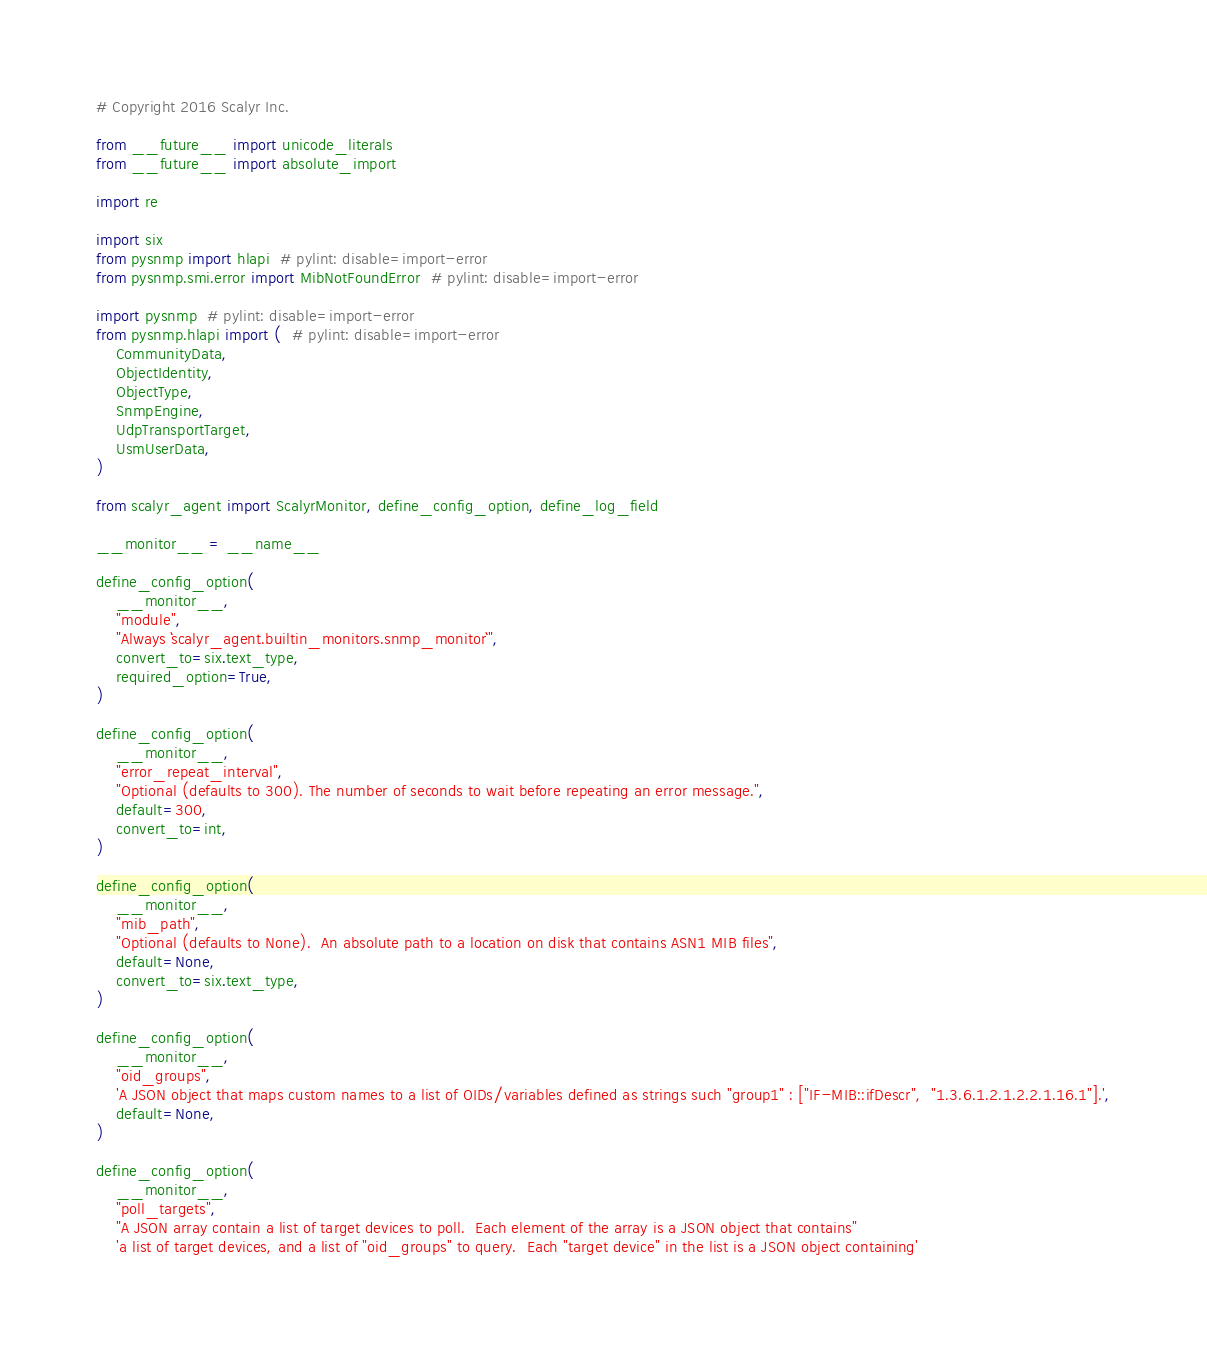Convert code to text. <code><loc_0><loc_0><loc_500><loc_500><_Python_># Copyright 2016 Scalyr Inc.

from __future__ import unicode_literals
from __future__ import absolute_import

import re

import six
from pysnmp import hlapi  # pylint: disable=import-error
from pysnmp.smi.error import MibNotFoundError  # pylint: disable=import-error

import pysnmp  # pylint: disable=import-error
from pysnmp.hlapi import (  # pylint: disable=import-error
    CommunityData,
    ObjectIdentity,
    ObjectType,
    SnmpEngine,
    UdpTransportTarget,
    UsmUserData,
)

from scalyr_agent import ScalyrMonitor, define_config_option, define_log_field

__monitor__ = __name__

define_config_option(
    __monitor__,
    "module",
    "Always ``scalyr_agent.builtin_monitors.snmp_monitor``",
    convert_to=six.text_type,
    required_option=True,
)

define_config_option(
    __monitor__,
    "error_repeat_interval",
    "Optional (defaults to 300). The number of seconds to wait before repeating an error message.",
    default=300,
    convert_to=int,
)

define_config_option(
    __monitor__,
    "mib_path",
    "Optional (defaults to None).  An absolute path to a location on disk that contains ASN1 MIB files",
    default=None,
    convert_to=six.text_type,
)

define_config_option(
    __monitor__,
    "oid_groups",
    'A JSON object that maps custom names to a list of OIDs/variables defined as strings such "group1" : ["IF-MIB::ifDescr",  "1.3.6.1.2.1.2.2.1.16.1"].',
    default=None,
)

define_config_option(
    __monitor__,
    "poll_targets",
    "A JSON array contain a list of target devices to poll.  Each element of the array is a JSON object that contains"
    'a list of target devices, and a list of "oid_groups" to query.  Each "target device" in the list is a JSON object containing'</code> 